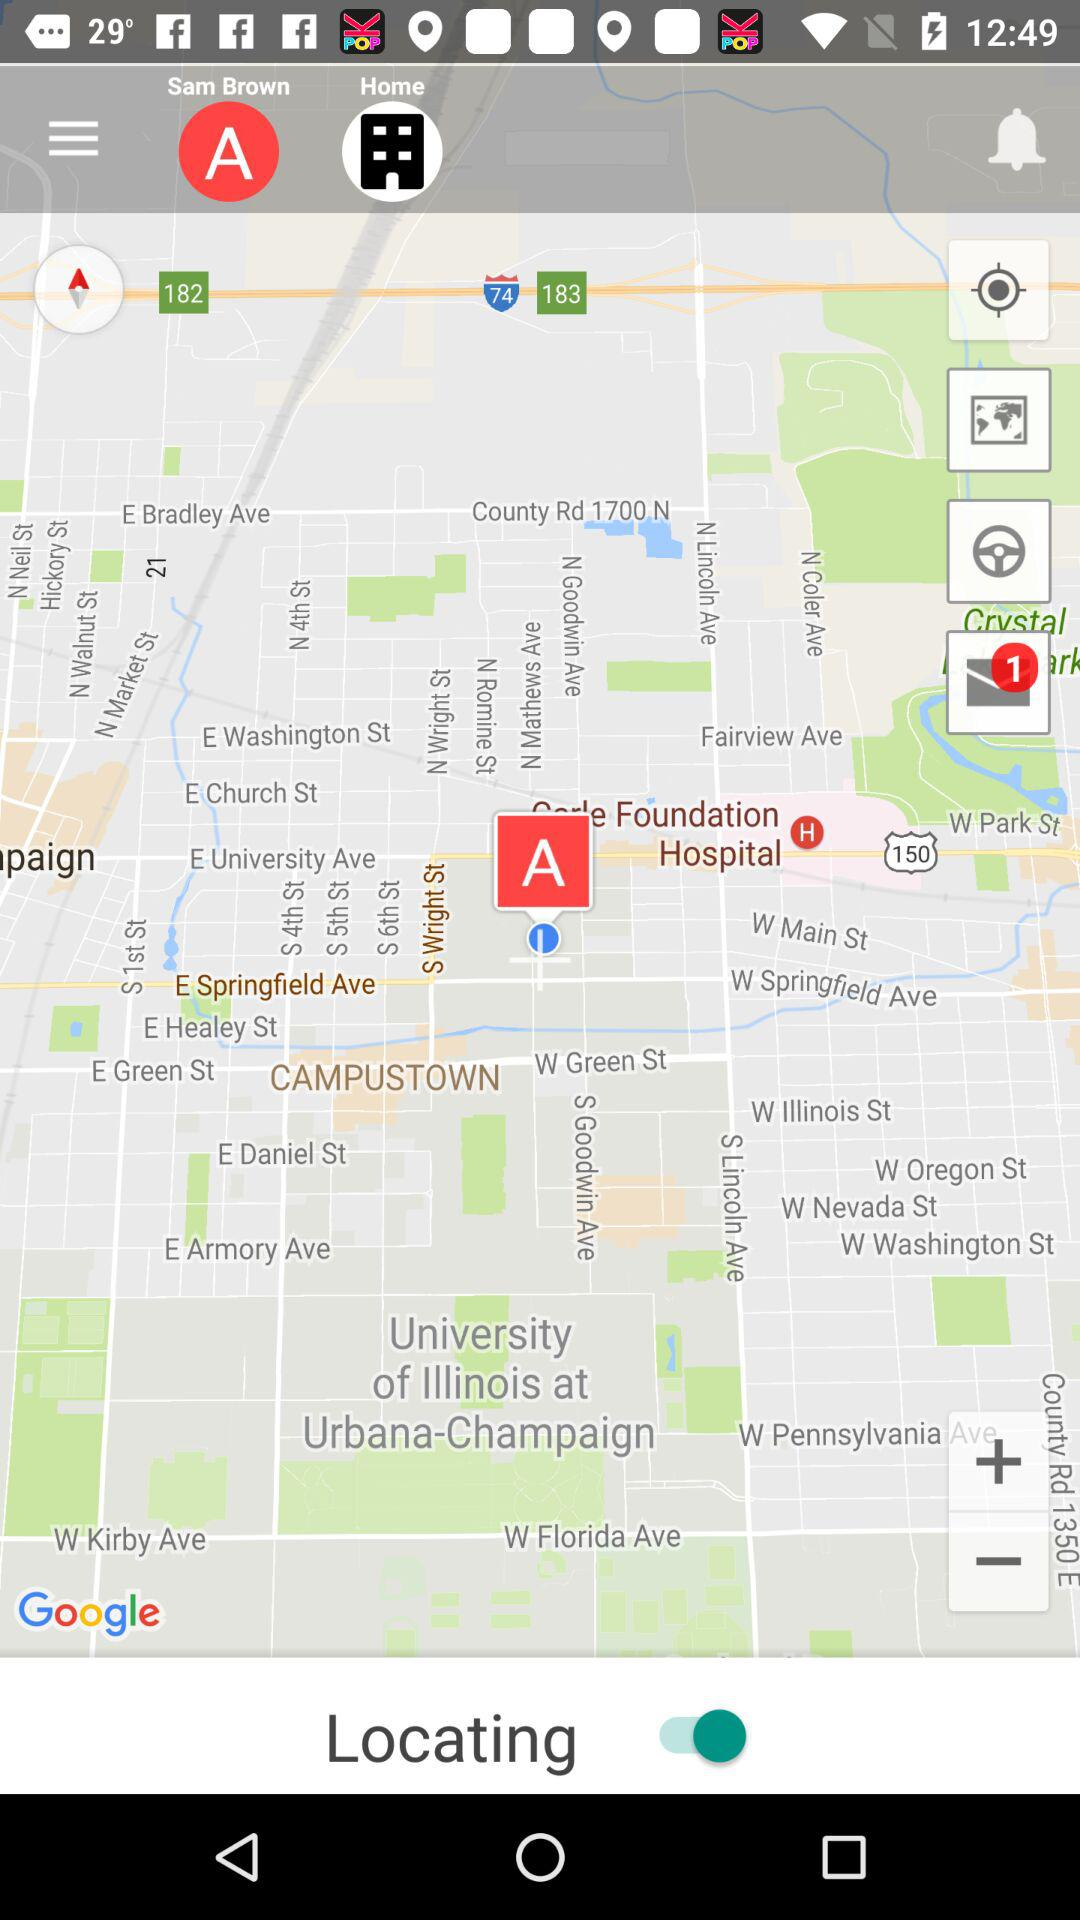What is the name of the user? The name of the user is Sam Brown. 